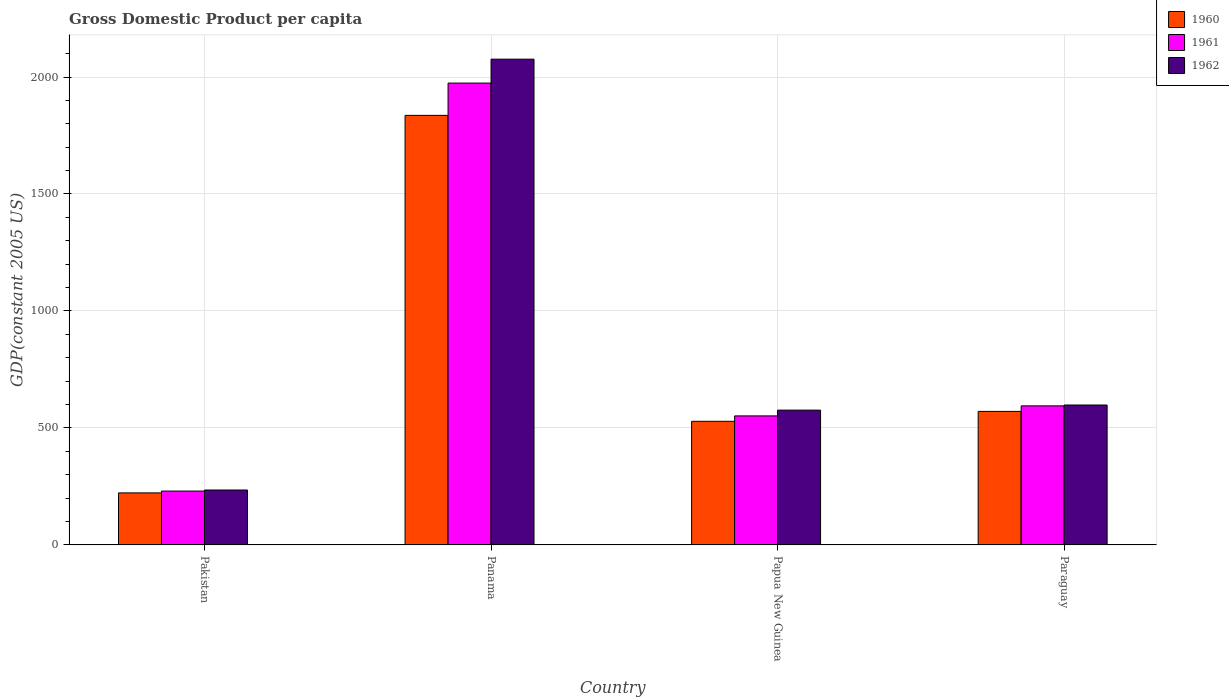How many groups of bars are there?
Ensure brevity in your answer.  4. Are the number of bars per tick equal to the number of legend labels?
Keep it short and to the point. Yes. How many bars are there on the 4th tick from the left?
Provide a succinct answer. 3. How many bars are there on the 1st tick from the right?
Give a very brief answer. 3. What is the GDP per capita in 1962 in Paraguay?
Your response must be concise. 598.08. Across all countries, what is the maximum GDP per capita in 1961?
Provide a short and direct response. 1974.02. Across all countries, what is the minimum GDP per capita in 1960?
Offer a terse response. 222.44. In which country was the GDP per capita in 1962 maximum?
Make the answer very short. Panama. What is the total GDP per capita in 1960 in the graph?
Give a very brief answer. 3157.66. What is the difference between the GDP per capita in 1962 in Panama and that in Paraguay?
Provide a succinct answer. 1478.21. What is the difference between the GDP per capita in 1962 in Pakistan and the GDP per capita in 1961 in Panama?
Make the answer very short. -1739.25. What is the average GDP per capita in 1960 per country?
Make the answer very short. 789.42. What is the difference between the GDP per capita of/in 1961 and GDP per capita of/in 1960 in Paraguay?
Offer a very short reply. 23.62. What is the ratio of the GDP per capita in 1960 in Panama to that in Papua New Guinea?
Offer a very short reply. 3.47. Is the difference between the GDP per capita in 1961 in Pakistan and Papua New Guinea greater than the difference between the GDP per capita in 1960 in Pakistan and Papua New Guinea?
Offer a very short reply. No. What is the difference between the highest and the second highest GDP per capita in 1961?
Your answer should be very brief. -1379.63. What is the difference between the highest and the lowest GDP per capita in 1962?
Your answer should be compact. 1841.51. In how many countries, is the GDP per capita in 1960 greater than the average GDP per capita in 1960 taken over all countries?
Your answer should be very brief. 1. What does the 3rd bar from the left in Panama represents?
Offer a terse response. 1962. How many bars are there?
Your answer should be very brief. 12. Are all the bars in the graph horizontal?
Ensure brevity in your answer.  No. How many countries are there in the graph?
Make the answer very short. 4. What is the difference between two consecutive major ticks on the Y-axis?
Your response must be concise. 500. Are the values on the major ticks of Y-axis written in scientific E-notation?
Keep it short and to the point. No. Does the graph contain any zero values?
Give a very brief answer. No. How are the legend labels stacked?
Provide a succinct answer. Vertical. What is the title of the graph?
Ensure brevity in your answer.  Gross Domestic Product per capita. What is the label or title of the X-axis?
Give a very brief answer. Country. What is the label or title of the Y-axis?
Make the answer very short. GDP(constant 2005 US). What is the GDP(constant 2005 US) of 1960 in Pakistan?
Make the answer very short. 222.44. What is the GDP(constant 2005 US) in 1961 in Pakistan?
Make the answer very short. 230.24. What is the GDP(constant 2005 US) in 1962 in Pakistan?
Your answer should be very brief. 234.77. What is the GDP(constant 2005 US) of 1960 in Panama?
Make the answer very short. 1836.06. What is the GDP(constant 2005 US) of 1961 in Panama?
Keep it short and to the point. 1974.02. What is the GDP(constant 2005 US) of 1962 in Panama?
Give a very brief answer. 2076.28. What is the GDP(constant 2005 US) in 1960 in Papua New Guinea?
Provide a short and direct response. 528.4. What is the GDP(constant 2005 US) of 1961 in Papua New Guinea?
Ensure brevity in your answer.  551.5. What is the GDP(constant 2005 US) in 1962 in Papua New Guinea?
Your answer should be compact. 576.26. What is the GDP(constant 2005 US) in 1960 in Paraguay?
Provide a short and direct response. 570.76. What is the GDP(constant 2005 US) of 1961 in Paraguay?
Ensure brevity in your answer.  594.38. What is the GDP(constant 2005 US) of 1962 in Paraguay?
Give a very brief answer. 598.08. Across all countries, what is the maximum GDP(constant 2005 US) of 1960?
Ensure brevity in your answer.  1836.06. Across all countries, what is the maximum GDP(constant 2005 US) of 1961?
Offer a very short reply. 1974.02. Across all countries, what is the maximum GDP(constant 2005 US) in 1962?
Your response must be concise. 2076.28. Across all countries, what is the minimum GDP(constant 2005 US) in 1960?
Your answer should be compact. 222.44. Across all countries, what is the minimum GDP(constant 2005 US) of 1961?
Provide a short and direct response. 230.24. Across all countries, what is the minimum GDP(constant 2005 US) in 1962?
Provide a succinct answer. 234.77. What is the total GDP(constant 2005 US) in 1960 in the graph?
Ensure brevity in your answer.  3157.66. What is the total GDP(constant 2005 US) of 1961 in the graph?
Offer a terse response. 3350.14. What is the total GDP(constant 2005 US) of 1962 in the graph?
Offer a very short reply. 3485.38. What is the difference between the GDP(constant 2005 US) in 1960 in Pakistan and that in Panama?
Ensure brevity in your answer.  -1613.62. What is the difference between the GDP(constant 2005 US) of 1961 in Pakistan and that in Panama?
Offer a very short reply. -1743.78. What is the difference between the GDP(constant 2005 US) in 1962 in Pakistan and that in Panama?
Your answer should be compact. -1841.51. What is the difference between the GDP(constant 2005 US) in 1960 in Pakistan and that in Papua New Guinea?
Give a very brief answer. -305.96. What is the difference between the GDP(constant 2005 US) of 1961 in Pakistan and that in Papua New Guinea?
Offer a terse response. -321.26. What is the difference between the GDP(constant 2005 US) in 1962 in Pakistan and that in Papua New Guinea?
Your response must be concise. -341.49. What is the difference between the GDP(constant 2005 US) in 1960 in Pakistan and that in Paraguay?
Your answer should be very brief. -348.32. What is the difference between the GDP(constant 2005 US) in 1961 in Pakistan and that in Paraguay?
Provide a short and direct response. -364.14. What is the difference between the GDP(constant 2005 US) in 1962 in Pakistan and that in Paraguay?
Ensure brevity in your answer.  -363.31. What is the difference between the GDP(constant 2005 US) in 1960 in Panama and that in Papua New Guinea?
Your answer should be very brief. 1307.66. What is the difference between the GDP(constant 2005 US) in 1961 in Panama and that in Papua New Guinea?
Keep it short and to the point. 1422.51. What is the difference between the GDP(constant 2005 US) in 1962 in Panama and that in Papua New Guinea?
Your answer should be very brief. 1500.03. What is the difference between the GDP(constant 2005 US) in 1960 in Panama and that in Paraguay?
Make the answer very short. 1265.3. What is the difference between the GDP(constant 2005 US) in 1961 in Panama and that in Paraguay?
Offer a terse response. 1379.63. What is the difference between the GDP(constant 2005 US) of 1962 in Panama and that in Paraguay?
Provide a short and direct response. 1478.21. What is the difference between the GDP(constant 2005 US) of 1960 in Papua New Guinea and that in Paraguay?
Provide a short and direct response. -42.36. What is the difference between the GDP(constant 2005 US) in 1961 in Papua New Guinea and that in Paraguay?
Provide a short and direct response. -42.88. What is the difference between the GDP(constant 2005 US) of 1962 in Papua New Guinea and that in Paraguay?
Offer a very short reply. -21.82. What is the difference between the GDP(constant 2005 US) of 1960 in Pakistan and the GDP(constant 2005 US) of 1961 in Panama?
Offer a terse response. -1751.58. What is the difference between the GDP(constant 2005 US) of 1960 in Pakistan and the GDP(constant 2005 US) of 1962 in Panama?
Offer a terse response. -1853.84. What is the difference between the GDP(constant 2005 US) in 1961 in Pakistan and the GDP(constant 2005 US) in 1962 in Panama?
Keep it short and to the point. -1846.04. What is the difference between the GDP(constant 2005 US) in 1960 in Pakistan and the GDP(constant 2005 US) in 1961 in Papua New Guinea?
Keep it short and to the point. -329.06. What is the difference between the GDP(constant 2005 US) of 1960 in Pakistan and the GDP(constant 2005 US) of 1962 in Papua New Guinea?
Keep it short and to the point. -353.82. What is the difference between the GDP(constant 2005 US) in 1961 in Pakistan and the GDP(constant 2005 US) in 1962 in Papua New Guinea?
Your answer should be compact. -346.02. What is the difference between the GDP(constant 2005 US) in 1960 in Pakistan and the GDP(constant 2005 US) in 1961 in Paraguay?
Your answer should be compact. -371.94. What is the difference between the GDP(constant 2005 US) of 1960 in Pakistan and the GDP(constant 2005 US) of 1962 in Paraguay?
Your answer should be compact. -375.64. What is the difference between the GDP(constant 2005 US) in 1961 in Pakistan and the GDP(constant 2005 US) in 1962 in Paraguay?
Provide a short and direct response. -367.84. What is the difference between the GDP(constant 2005 US) in 1960 in Panama and the GDP(constant 2005 US) in 1961 in Papua New Guinea?
Your answer should be very brief. 1284.56. What is the difference between the GDP(constant 2005 US) of 1960 in Panama and the GDP(constant 2005 US) of 1962 in Papua New Guinea?
Your answer should be very brief. 1259.81. What is the difference between the GDP(constant 2005 US) of 1961 in Panama and the GDP(constant 2005 US) of 1962 in Papua New Guinea?
Your response must be concise. 1397.76. What is the difference between the GDP(constant 2005 US) of 1960 in Panama and the GDP(constant 2005 US) of 1961 in Paraguay?
Make the answer very short. 1241.68. What is the difference between the GDP(constant 2005 US) of 1960 in Panama and the GDP(constant 2005 US) of 1962 in Paraguay?
Your response must be concise. 1237.98. What is the difference between the GDP(constant 2005 US) in 1961 in Panama and the GDP(constant 2005 US) in 1962 in Paraguay?
Give a very brief answer. 1375.94. What is the difference between the GDP(constant 2005 US) of 1960 in Papua New Guinea and the GDP(constant 2005 US) of 1961 in Paraguay?
Provide a short and direct response. -65.98. What is the difference between the GDP(constant 2005 US) of 1960 in Papua New Guinea and the GDP(constant 2005 US) of 1962 in Paraguay?
Offer a very short reply. -69.68. What is the difference between the GDP(constant 2005 US) in 1961 in Papua New Guinea and the GDP(constant 2005 US) in 1962 in Paraguay?
Provide a short and direct response. -46.57. What is the average GDP(constant 2005 US) in 1960 per country?
Your answer should be very brief. 789.42. What is the average GDP(constant 2005 US) of 1961 per country?
Make the answer very short. 837.54. What is the average GDP(constant 2005 US) of 1962 per country?
Provide a short and direct response. 871.35. What is the difference between the GDP(constant 2005 US) in 1960 and GDP(constant 2005 US) in 1961 in Pakistan?
Provide a short and direct response. -7.8. What is the difference between the GDP(constant 2005 US) in 1960 and GDP(constant 2005 US) in 1962 in Pakistan?
Ensure brevity in your answer.  -12.33. What is the difference between the GDP(constant 2005 US) of 1961 and GDP(constant 2005 US) of 1962 in Pakistan?
Your answer should be very brief. -4.53. What is the difference between the GDP(constant 2005 US) in 1960 and GDP(constant 2005 US) in 1961 in Panama?
Give a very brief answer. -137.96. What is the difference between the GDP(constant 2005 US) in 1960 and GDP(constant 2005 US) in 1962 in Panama?
Make the answer very short. -240.22. What is the difference between the GDP(constant 2005 US) in 1961 and GDP(constant 2005 US) in 1962 in Panama?
Offer a terse response. -102.27. What is the difference between the GDP(constant 2005 US) in 1960 and GDP(constant 2005 US) in 1961 in Papua New Guinea?
Offer a terse response. -23.1. What is the difference between the GDP(constant 2005 US) of 1960 and GDP(constant 2005 US) of 1962 in Papua New Guinea?
Give a very brief answer. -47.85. What is the difference between the GDP(constant 2005 US) in 1961 and GDP(constant 2005 US) in 1962 in Papua New Guinea?
Ensure brevity in your answer.  -24.75. What is the difference between the GDP(constant 2005 US) in 1960 and GDP(constant 2005 US) in 1961 in Paraguay?
Give a very brief answer. -23.62. What is the difference between the GDP(constant 2005 US) in 1960 and GDP(constant 2005 US) in 1962 in Paraguay?
Your response must be concise. -27.32. What is the difference between the GDP(constant 2005 US) in 1961 and GDP(constant 2005 US) in 1962 in Paraguay?
Your response must be concise. -3.69. What is the ratio of the GDP(constant 2005 US) in 1960 in Pakistan to that in Panama?
Provide a short and direct response. 0.12. What is the ratio of the GDP(constant 2005 US) of 1961 in Pakistan to that in Panama?
Keep it short and to the point. 0.12. What is the ratio of the GDP(constant 2005 US) of 1962 in Pakistan to that in Panama?
Provide a short and direct response. 0.11. What is the ratio of the GDP(constant 2005 US) in 1960 in Pakistan to that in Papua New Guinea?
Your answer should be compact. 0.42. What is the ratio of the GDP(constant 2005 US) in 1961 in Pakistan to that in Papua New Guinea?
Offer a terse response. 0.42. What is the ratio of the GDP(constant 2005 US) of 1962 in Pakistan to that in Papua New Guinea?
Give a very brief answer. 0.41. What is the ratio of the GDP(constant 2005 US) of 1960 in Pakistan to that in Paraguay?
Give a very brief answer. 0.39. What is the ratio of the GDP(constant 2005 US) of 1961 in Pakistan to that in Paraguay?
Offer a terse response. 0.39. What is the ratio of the GDP(constant 2005 US) of 1962 in Pakistan to that in Paraguay?
Provide a short and direct response. 0.39. What is the ratio of the GDP(constant 2005 US) in 1960 in Panama to that in Papua New Guinea?
Provide a succinct answer. 3.47. What is the ratio of the GDP(constant 2005 US) of 1961 in Panama to that in Papua New Guinea?
Ensure brevity in your answer.  3.58. What is the ratio of the GDP(constant 2005 US) of 1962 in Panama to that in Papua New Guinea?
Provide a short and direct response. 3.6. What is the ratio of the GDP(constant 2005 US) in 1960 in Panama to that in Paraguay?
Make the answer very short. 3.22. What is the ratio of the GDP(constant 2005 US) in 1961 in Panama to that in Paraguay?
Your response must be concise. 3.32. What is the ratio of the GDP(constant 2005 US) in 1962 in Panama to that in Paraguay?
Give a very brief answer. 3.47. What is the ratio of the GDP(constant 2005 US) of 1960 in Papua New Guinea to that in Paraguay?
Your answer should be very brief. 0.93. What is the ratio of the GDP(constant 2005 US) in 1961 in Papua New Guinea to that in Paraguay?
Your response must be concise. 0.93. What is the ratio of the GDP(constant 2005 US) of 1962 in Papua New Guinea to that in Paraguay?
Offer a terse response. 0.96. What is the difference between the highest and the second highest GDP(constant 2005 US) in 1960?
Your response must be concise. 1265.3. What is the difference between the highest and the second highest GDP(constant 2005 US) of 1961?
Offer a terse response. 1379.63. What is the difference between the highest and the second highest GDP(constant 2005 US) of 1962?
Ensure brevity in your answer.  1478.21. What is the difference between the highest and the lowest GDP(constant 2005 US) in 1960?
Provide a succinct answer. 1613.62. What is the difference between the highest and the lowest GDP(constant 2005 US) of 1961?
Provide a short and direct response. 1743.78. What is the difference between the highest and the lowest GDP(constant 2005 US) of 1962?
Offer a terse response. 1841.51. 